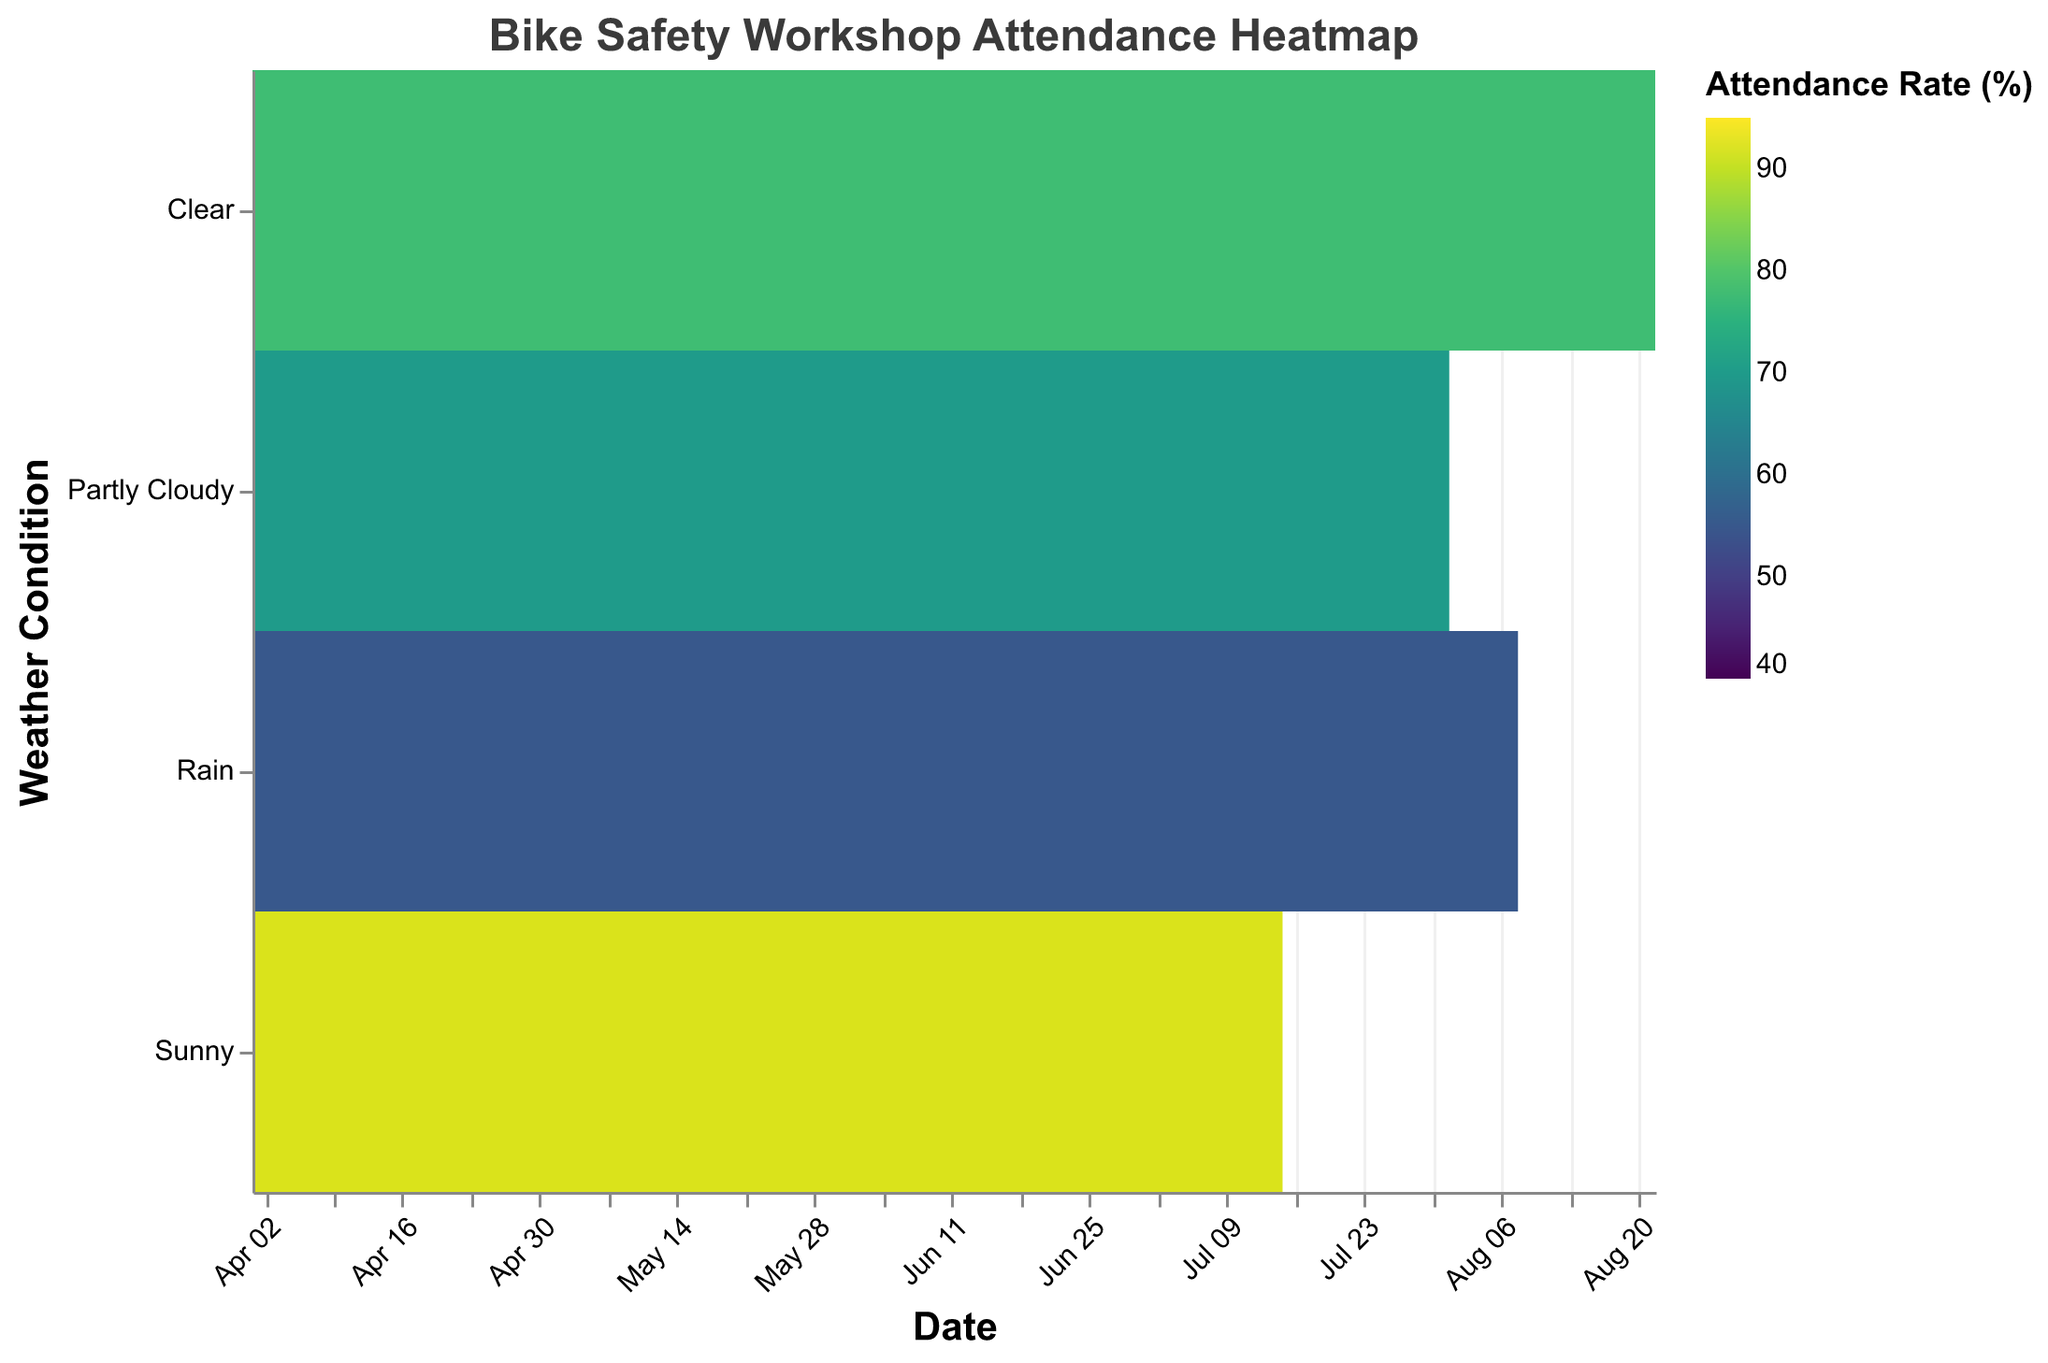How many different weather conditions are visualized on the heatmap? Look at the y-axis on the heatmap, which lists the different weather conditions. Count the unique labels present on this axis.
Answer: 4 What is the attendance rate on June 1st, and what was the weather condition on that day? Hover over the rectangle associated with June 1st on the x-axis. The tooltip will display additional details, including the attendance rate and weather condition.
Answer: 65%, Partly Cloudy What was the highest attendance rate recorded, and under what weather condition and date did it occur? Identify the rectangle with the darkest color, which represents the highest attendance rate. Hover over it to reveal detailed information about the attendance rate, weather condition, and date.
Answer: 95%, Sunny, July 1st How does the attendance rate generally compare between rainy days and sunny days? Observe the color intensity of rectangles corresponding to "Rain" and "Sunny" on the y-axis. Generally, if the colors are darker for sunny days than rainy days, it indicates higher attendance rates for sunny days.
Answer: Generally higher on sunny days Is there a trend in attendance rates during school holidays compared to non-holiday periods? Hover over rectangles marked with "Yes" for School Holidays and compare the color hues to those marked with "No". Darker hues during holidays suggest higher attendance.
Answer: Higher during school holidays On what date did a clear weather day have a lower attendance rate than a rainy day? Identify the clear weather days on the y-axis, and note their colors and dates. Do the same for rainy days and compare the attendance rates to find the asked condition.
Answer: April 1 (Clear) < April 15 (Rain) Which month observed the lowest attendance rate, and what was the weather during that period? Identify the rectangle with the lightest color, representing the lowest attendance rate, and hover over it to get the details.
Answer: May, Rain Does precipitation seem to have a direct impact on attendance rates? Observe the relationship between precipitation values shown in the tooltips and the color gradient in attendance rates. Higher precipitation values likely correspond to lighter colors indicating lower attendance rates.
Answer: Higher precipitation = lower attendance rates What is the average attendance rate during non-school holidays in June? There are 3 non-holiday dates in June (8th, 15th, and 22nd) with attendance rates of 80%, 85%, and 90%. Calculate the average by summing these values and dividing by 3.
Answer: (80 + 85 + 90) / 3 = 85% How does the attendance rate on partly cloudy days compare between school holidays and non-school holidays? Compare rectangles indicating "Partly Cloudy" weather under conditions marked as school holidays ("Yes") and non-school holidays ("No"). Summarize the comparison based on the color hues.
Answer: Higher on school holidays 